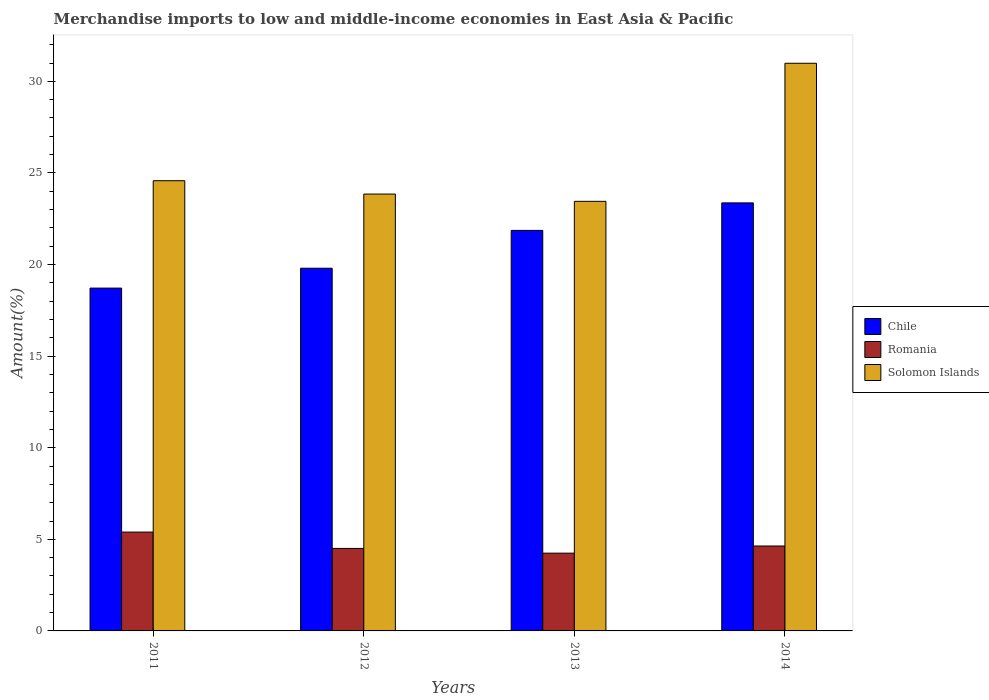How many different coloured bars are there?
Your answer should be very brief. 3. How many groups of bars are there?
Provide a succinct answer. 4. Are the number of bars on each tick of the X-axis equal?
Provide a succinct answer. Yes. How many bars are there on the 1st tick from the left?
Your answer should be very brief. 3. How many bars are there on the 1st tick from the right?
Provide a short and direct response. 3. What is the label of the 2nd group of bars from the left?
Make the answer very short. 2012. In how many cases, is the number of bars for a given year not equal to the number of legend labels?
Make the answer very short. 0. What is the percentage of amount earned from merchandise imports in Romania in 2011?
Your response must be concise. 5.4. Across all years, what is the maximum percentage of amount earned from merchandise imports in Solomon Islands?
Offer a very short reply. 30.99. Across all years, what is the minimum percentage of amount earned from merchandise imports in Romania?
Give a very brief answer. 4.25. In which year was the percentage of amount earned from merchandise imports in Solomon Islands minimum?
Ensure brevity in your answer.  2013. What is the total percentage of amount earned from merchandise imports in Chile in the graph?
Provide a succinct answer. 83.74. What is the difference between the percentage of amount earned from merchandise imports in Solomon Islands in 2011 and that in 2014?
Offer a terse response. -6.41. What is the difference between the percentage of amount earned from merchandise imports in Romania in 2014 and the percentage of amount earned from merchandise imports in Chile in 2012?
Your answer should be very brief. -15.16. What is the average percentage of amount earned from merchandise imports in Romania per year?
Your answer should be very brief. 4.7. In the year 2011, what is the difference between the percentage of amount earned from merchandise imports in Chile and percentage of amount earned from merchandise imports in Solomon Islands?
Provide a short and direct response. -5.86. In how many years, is the percentage of amount earned from merchandise imports in Romania greater than 30 %?
Offer a terse response. 0. What is the ratio of the percentage of amount earned from merchandise imports in Solomon Islands in 2011 to that in 2013?
Ensure brevity in your answer.  1.05. Is the percentage of amount earned from merchandise imports in Chile in 2012 less than that in 2014?
Offer a very short reply. Yes. Is the difference between the percentage of amount earned from merchandise imports in Chile in 2011 and 2013 greater than the difference between the percentage of amount earned from merchandise imports in Solomon Islands in 2011 and 2013?
Give a very brief answer. No. What is the difference between the highest and the second highest percentage of amount earned from merchandise imports in Solomon Islands?
Make the answer very short. 6.41. What is the difference between the highest and the lowest percentage of amount earned from merchandise imports in Romania?
Offer a very short reply. 1.15. In how many years, is the percentage of amount earned from merchandise imports in Romania greater than the average percentage of amount earned from merchandise imports in Romania taken over all years?
Ensure brevity in your answer.  1. What does the 2nd bar from the left in 2012 represents?
Make the answer very short. Romania. What does the 1st bar from the right in 2012 represents?
Keep it short and to the point. Solomon Islands. Is it the case that in every year, the sum of the percentage of amount earned from merchandise imports in Romania and percentage of amount earned from merchandise imports in Solomon Islands is greater than the percentage of amount earned from merchandise imports in Chile?
Ensure brevity in your answer.  Yes. How many bars are there?
Ensure brevity in your answer.  12. Are the values on the major ticks of Y-axis written in scientific E-notation?
Offer a very short reply. No. Where does the legend appear in the graph?
Keep it short and to the point. Center right. How many legend labels are there?
Offer a terse response. 3. What is the title of the graph?
Give a very brief answer. Merchandise imports to low and middle-income economies in East Asia & Pacific. Does "Bhutan" appear as one of the legend labels in the graph?
Give a very brief answer. No. What is the label or title of the X-axis?
Provide a succinct answer. Years. What is the label or title of the Y-axis?
Make the answer very short. Amount(%). What is the Amount(%) of Chile in 2011?
Keep it short and to the point. 18.71. What is the Amount(%) in Romania in 2011?
Give a very brief answer. 5.4. What is the Amount(%) of Solomon Islands in 2011?
Offer a terse response. 24.58. What is the Amount(%) in Chile in 2012?
Offer a terse response. 19.8. What is the Amount(%) in Romania in 2012?
Keep it short and to the point. 4.5. What is the Amount(%) of Solomon Islands in 2012?
Your answer should be compact. 23.85. What is the Amount(%) in Chile in 2013?
Give a very brief answer. 21.86. What is the Amount(%) in Romania in 2013?
Give a very brief answer. 4.25. What is the Amount(%) of Solomon Islands in 2013?
Make the answer very short. 23.45. What is the Amount(%) of Chile in 2014?
Offer a terse response. 23.37. What is the Amount(%) of Romania in 2014?
Provide a short and direct response. 4.64. What is the Amount(%) in Solomon Islands in 2014?
Keep it short and to the point. 30.99. Across all years, what is the maximum Amount(%) in Chile?
Your answer should be compact. 23.37. Across all years, what is the maximum Amount(%) of Romania?
Your response must be concise. 5.4. Across all years, what is the maximum Amount(%) of Solomon Islands?
Keep it short and to the point. 30.99. Across all years, what is the minimum Amount(%) in Chile?
Provide a succinct answer. 18.71. Across all years, what is the minimum Amount(%) of Romania?
Your response must be concise. 4.25. Across all years, what is the minimum Amount(%) of Solomon Islands?
Provide a succinct answer. 23.45. What is the total Amount(%) in Chile in the graph?
Give a very brief answer. 83.74. What is the total Amount(%) of Romania in the graph?
Offer a terse response. 18.78. What is the total Amount(%) in Solomon Islands in the graph?
Offer a terse response. 102.86. What is the difference between the Amount(%) in Chile in 2011 and that in 2012?
Ensure brevity in your answer.  -1.08. What is the difference between the Amount(%) in Romania in 2011 and that in 2012?
Provide a short and direct response. 0.89. What is the difference between the Amount(%) in Solomon Islands in 2011 and that in 2012?
Your answer should be very brief. 0.73. What is the difference between the Amount(%) of Chile in 2011 and that in 2013?
Provide a succinct answer. -3.15. What is the difference between the Amount(%) of Romania in 2011 and that in 2013?
Keep it short and to the point. 1.15. What is the difference between the Amount(%) in Solomon Islands in 2011 and that in 2013?
Give a very brief answer. 1.13. What is the difference between the Amount(%) of Chile in 2011 and that in 2014?
Your response must be concise. -4.65. What is the difference between the Amount(%) of Romania in 2011 and that in 2014?
Offer a very short reply. 0.76. What is the difference between the Amount(%) of Solomon Islands in 2011 and that in 2014?
Provide a short and direct response. -6.41. What is the difference between the Amount(%) of Chile in 2012 and that in 2013?
Your answer should be compact. -2.07. What is the difference between the Amount(%) in Romania in 2012 and that in 2013?
Offer a very short reply. 0.26. What is the difference between the Amount(%) of Solomon Islands in 2012 and that in 2013?
Offer a terse response. 0.4. What is the difference between the Amount(%) of Chile in 2012 and that in 2014?
Your answer should be compact. -3.57. What is the difference between the Amount(%) of Romania in 2012 and that in 2014?
Keep it short and to the point. -0.13. What is the difference between the Amount(%) in Solomon Islands in 2012 and that in 2014?
Offer a very short reply. -7.14. What is the difference between the Amount(%) of Chile in 2013 and that in 2014?
Ensure brevity in your answer.  -1.5. What is the difference between the Amount(%) in Romania in 2013 and that in 2014?
Your answer should be very brief. -0.39. What is the difference between the Amount(%) in Solomon Islands in 2013 and that in 2014?
Your answer should be very brief. -7.54. What is the difference between the Amount(%) in Chile in 2011 and the Amount(%) in Romania in 2012?
Your response must be concise. 14.21. What is the difference between the Amount(%) of Chile in 2011 and the Amount(%) of Solomon Islands in 2012?
Your response must be concise. -5.13. What is the difference between the Amount(%) in Romania in 2011 and the Amount(%) in Solomon Islands in 2012?
Provide a succinct answer. -18.45. What is the difference between the Amount(%) in Chile in 2011 and the Amount(%) in Romania in 2013?
Your response must be concise. 14.47. What is the difference between the Amount(%) of Chile in 2011 and the Amount(%) of Solomon Islands in 2013?
Your answer should be compact. -4.74. What is the difference between the Amount(%) in Romania in 2011 and the Amount(%) in Solomon Islands in 2013?
Make the answer very short. -18.05. What is the difference between the Amount(%) of Chile in 2011 and the Amount(%) of Romania in 2014?
Your response must be concise. 14.08. What is the difference between the Amount(%) in Chile in 2011 and the Amount(%) in Solomon Islands in 2014?
Ensure brevity in your answer.  -12.27. What is the difference between the Amount(%) in Romania in 2011 and the Amount(%) in Solomon Islands in 2014?
Give a very brief answer. -25.59. What is the difference between the Amount(%) in Chile in 2012 and the Amount(%) in Romania in 2013?
Keep it short and to the point. 15.55. What is the difference between the Amount(%) in Chile in 2012 and the Amount(%) in Solomon Islands in 2013?
Provide a short and direct response. -3.65. What is the difference between the Amount(%) of Romania in 2012 and the Amount(%) of Solomon Islands in 2013?
Your answer should be very brief. -18.95. What is the difference between the Amount(%) in Chile in 2012 and the Amount(%) in Romania in 2014?
Give a very brief answer. 15.16. What is the difference between the Amount(%) of Chile in 2012 and the Amount(%) of Solomon Islands in 2014?
Provide a short and direct response. -11.19. What is the difference between the Amount(%) of Romania in 2012 and the Amount(%) of Solomon Islands in 2014?
Your response must be concise. -26.48. What is the difference between the Amount(%) in Chile in 2013 and the Amount(%) in Romania in 2014?
Offer a very short reply. 17.23. What is the difference between the Amount(%) of Chile in 2013 and the Amount(%) of Solomon Islands in 2014?
Give a very brief answer. -9.12. What is the difference between the Amount(%) in Romania in 2013 and the Amount(%) in Solomon Islands in 2014?
Give a very brief answer. -26.74. What is the average Amount(%) of Chile per year?
Ensure brevity in your answer.  20.94. What is the average Amount(%) in Romania per year?
Give a very brief answer. 4.7. What is the average Amount(%) in Solomon Islands per year?
Your answer should be very brief. 25.72. In the year 2011, what is the difference between the Amount(%) of Chile and Amount(%) of Romania?
Ensure brevity in your answer.  13.32. In the year 2011, what is the difference between the Amount(%) of Chile and Amount(%) of Solomon Islands?
Make the answer very short. -5.86. In the year 2011, what is the difference between the Amount(%) of Romania and Amount(%) of Solomon Islands?
Provide a short and direct response. -19.18. In the year 2012, what is the difference between the Amount(%) in Chile and Amount(%) in Romania?
Ensure brevity in your answer.  15.3. In the year 2012, what is the difference between the Amount(%) of Chile and Amount(%) of Solomon Islands?
Provide a short and direct response. -4.05. In the year 2012, what is the difference between the Amount(%) of Romania and Amount(%) of Solomon Islands?
Your answer should be very brief. -19.34. In the year 2013, what is the difference between the Amount(%) in Chile and Amount(%) in Romania?
Your response must be concise. 17.62. In the year 2013, what is the difference between the Amount(%) in Chile and Amount(%) in Solomon Islands?
Make the answer very short. -1.59. In the year 2013, what is the difference between the Amount(%) of Romania and Amount(%) of Solomon Islands?
Offer a terse response. -19.2. In the year 2014, what is the difference between the Amount(%) of Chile and Amount(%) of Romania?
Provide a short and direct response. 18.73. In the year 2014, what is the difference between the Amount(%) in Chile and Amount(%) in Solomon Islands?
Give a very brief answer. -7.62. In the year 2014, what is the difference between the Amount(%) of Romania and Amount(%) of Solomon Islands?
Your response must be concise. -26.35. What is the ratio of the Amount(%) in Chile in 2011 to that in 2012?
Offer a terse response. 0.95. What is the ratio of the Amount(%) of Romania in 2011 to that in 2012?
Provide a succinct answer. 1.2. What is the ratio of the Amount(%) in Solomon Islands in 2011 to that in 2012?
Offer a terse response. 1.03. What is the ratio of the Amount(%) of Chile in 2011 to that in 2013?
Your answer should be very brief. 0.86. What is the ratio of the Amount(%) in Romania in 2011 to that in 2013?
Keep it short and to the point. 1.27. What is the ratio of the Amount(%) of Solomon Islands in 2011 to that in 2013?
Provide a succinct answer. 1.05. What is the ratio of the Amount(%) in Chile in 2011 to that in 2014?
Provide a short and direct response. 0.8. What is the ratio of the Amount(%) of Romania in 2011 to that in 2014?
Provide a short and direct response. 1.16. What is the ratio of the Amount(%) in Solomon Islands in 2011 to that in 2014?
Your answer should be compact. 0.79. What is the ratio of the Amount(%) in Chile in 2012 to that in 2013?
Your answer should be very brief. 0.91. What is the ratio of the Amount(%) in Romania in 2012 to that in 2013?
Your answer should be very brief. 1.06. What is the ratio of the Amount(%) of Solomon Islands in 2012 to that in 2013?
Ensure brevity in your answer.  1.02. What is the ratio of the Amount(%) in Chile in 2012 to that in 2014?
Your answer should be very brief. 0.85. What is the ratio of the Amount(%) in Romania in 2012 to that in 2014?
Ensure brevity in your answer.  0.97. What is the ratio of the Amount(%) of Solomon Islands in 2012 to that in 2014?
Provide a succinct answer. 0.77. What is the ratio of the Amount(%) of Chile in 2013 to that in 2014?
Your response must be concise. 0.94. What is the ratio of the Amount(%) in Romania in 2013 to that in 2014?
Your answer should be compact. 0.92. What is the ratio of the Amount(%) in Solomon Islands in 2013 to that in 2014?
Make the answer very short. 0.76. What is the difference between the highest and the second highest Amount(%) in Chile?
Ensure brevity in your answer.  1.5. What is the difference between the highest and the second highest Amount(%) in Romania?
Offer a very short reply. 0.76. What is the difference between the highest and the second highest Amount(%) of Solomon Islands?
Offer a terse response. 6.41. What is the difference between the highest and the lowest Amount(%) of Chile?
Offer a terse response. 4.65. What is the difference between the highest and the lowest Amount(%) in Romania?
Your answer should be compact. 1.15. What is the difference between the highest and the lowest Amount(%) in Solomon Islands?
Provide a short and direct response. 7.54. 